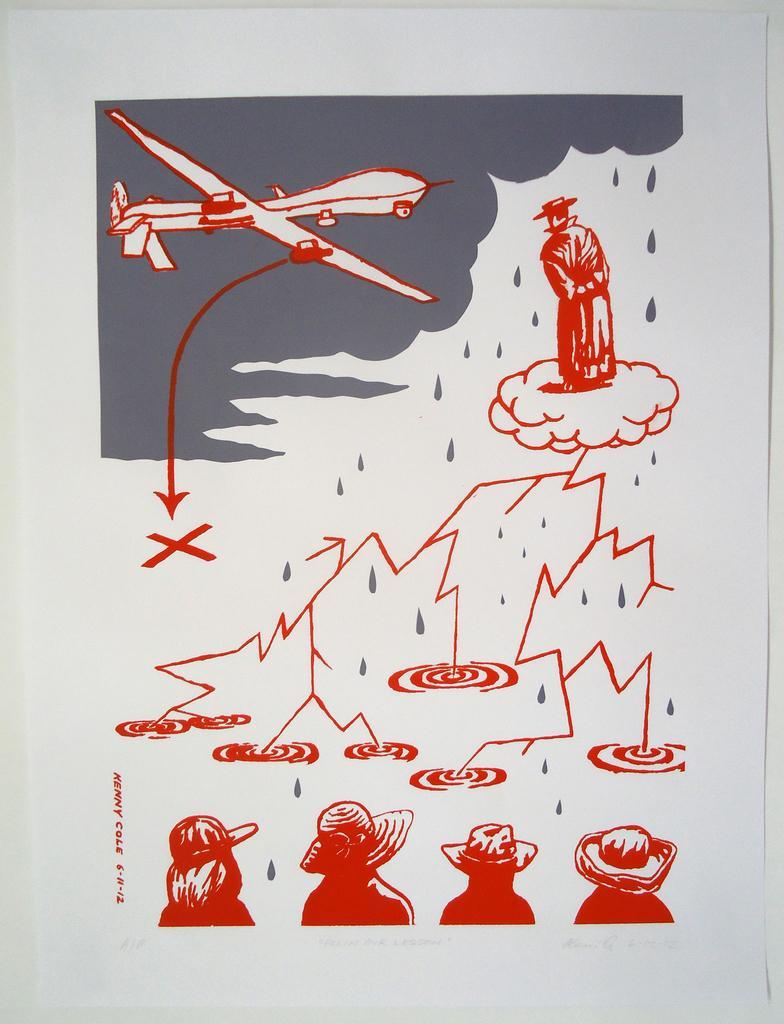Can you describe this image briefly? In this image I can see few people and an aircraft on the white color paper and the background is in white color. 